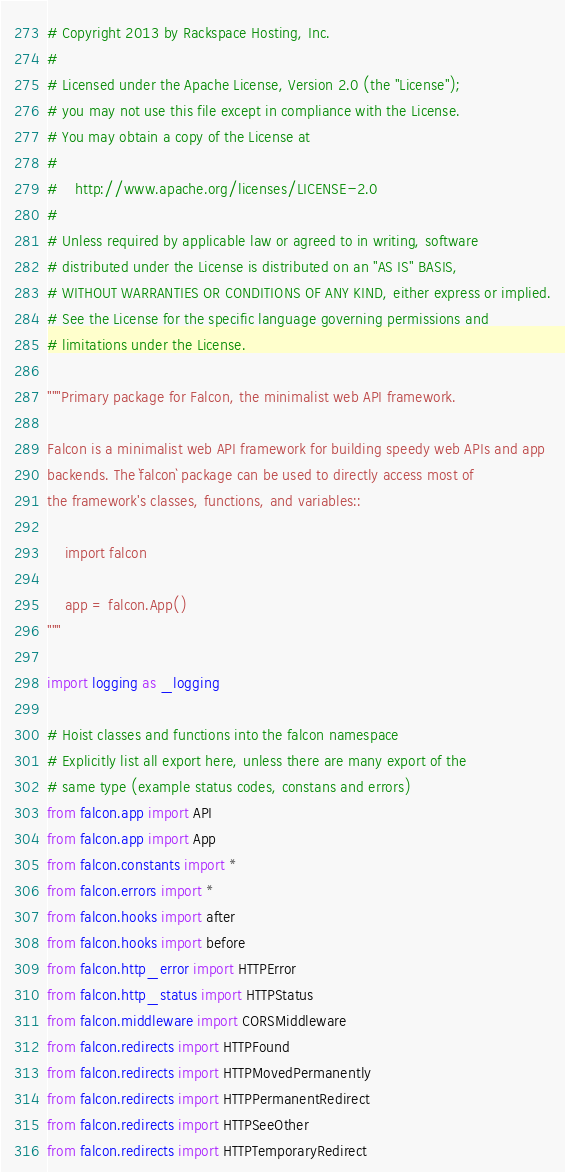Convert code to text. <code><loc_0><loc_0><loc_500><loc_500><_Python_># Copyright 2013 by Rackspace Hosting, Inc.
#
# Licensed under the Apache License, Version 2.0 (the "License");
# you may not use this file except in compliance with the License.
# You may obtain a copy of the License at
#
#    http://www.apache.org/licenses/LICENSE-2.0
#
# Unless required by applicable law or agreed to in writing, software
# distributed under the License is distributed on an "AS IS" BASIS,
# WITHOUT WARRANTIES OR CONDITIONS OF ANY KIND, either express or implied.
# See the License for the specific language governing permissions and
# limitations under the License.

"""Primary package for Falcon, the minimalist web API framework.

Falcon is a minimalist web API framework for building speedy web APIs and app
backends. The `falcon` package can be used to directly access most of
the framework's classes, functions, and variables::

    import falcon

    app = falcon.App()
"""

import logging as _logging

# Hoist classes and functions into the falcon namespace
# Explicitly list all export here, unless there are many export of the
# same type (example status codes, constans and errors)
from falcon.app import API
from falcon.app import App
from falcon.constants import *
from falcon.errors import *
from falcon.hooks import after
from falcon.hooks import before
from falcon.http_error import HTTPError
from falcon.http_status import HTTPStatus
from falcon.middleware import CORSMiddleware
from falcon.redirects import HTTPFound
from falcon.redirects import HTTPMovedPermanently
from falcon.redirects import HTTPPermanentRedirect
from falcon.redirects import HTTPSeeOther
from falcon.redirects import HTTPTemporaryRedirect</code> 